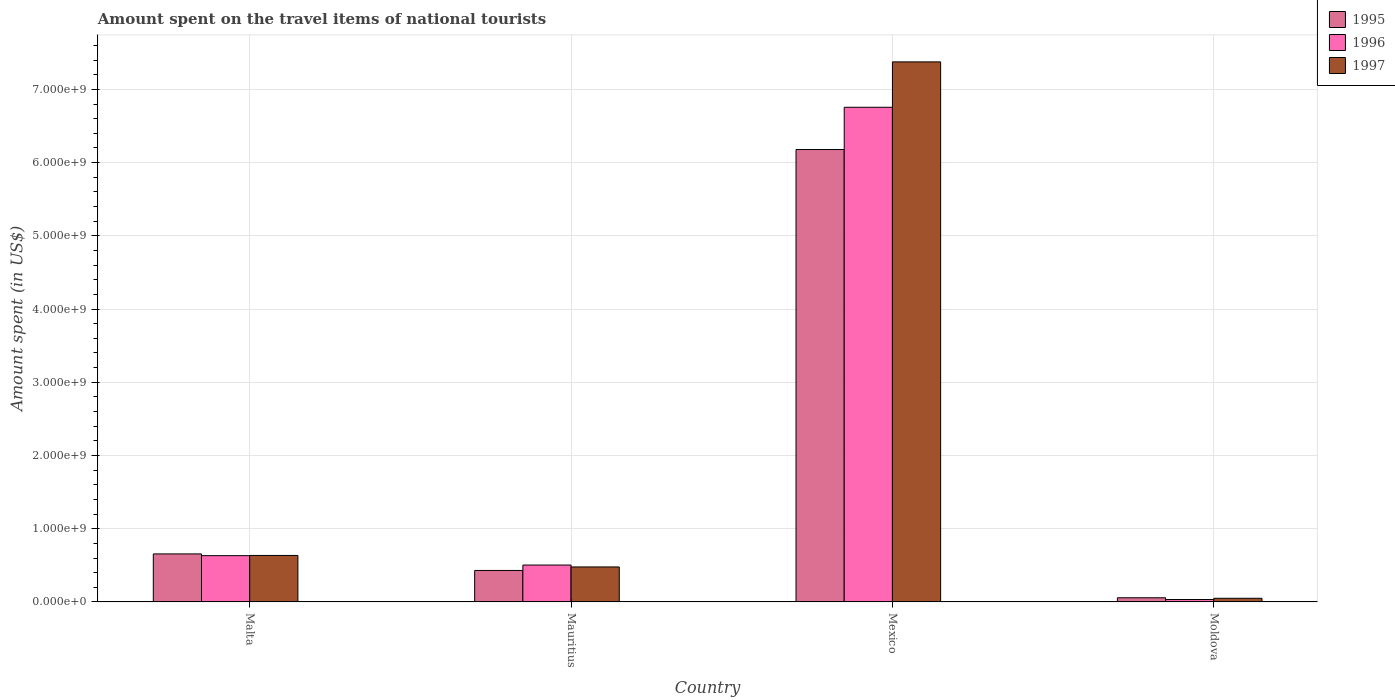How many bars are there on the 3rd tick from the right?
Keep it short and to the point. 3. What is the amount spent on the travel items of national tourists in 1996 in Mexico?
Provide a succinct answer. 6.76e+09. Across all countries, what is the maximum amount spent on the travel items of national tourists in 1996?
Keep it short and to the point. 6.76e+09. Across all countries, what is the minimum amount spent on the travel items of national tourists in 1995?
Provide a short and direct response. 5.70e+07. In which country was the amount spent on the travel items of national tourists in 1996 maximum?
Keep it short and to the point. Mexico. In which country was the amount spent on the travel items of national tourists in 1996 minimum?
Ensure brevity in your answer.  Moldova. What is the total amount spent on the travel items of national tourists in 1995 in the graph?
Offer a very short reply. 7.32e+09. What is the difference between the amount spent on the travel items of national tourists in 1996 in Mauritius and that in Moldova?
Provide a short and direct response. 4.71e+08. What is the difference between the amount spent on the travel items of national tourists in 1997 in Malta and the amount spent on the travel items of national tourists in 1996 in Moldova?
Offer a terse response. 6.02e+08. What is the average amount spent on the travel items of national tourists in 1995 per country?
Provide a succinct answer. 1.83e+09. What is the difference between the amount spent on the travel items of national tourists of/in 1995 and amount spent on the travel items of national tourists of/in 1996 in Malta?
Offer a very short reply. 2.40e+07. In how many countries, is the amount spent on the travel items of national tourists in 1995 greater than 5800000000 US$?
Make the answer very short. 1. What is the ratio of the amount spent on the travel items of national tourists in 1997 in Mauritius to that in Moldova?
Offer a very short reply. 9.56. Is the amount spent on the travel items of national tourists in 1995 in Malta less than that in Moldova?
Give a very brief answer. No. What is the difference between the highest and the second highest amount spent on the travel items of national tourists in 1997?
Keep it short and to the point. 6.90e+09. What is the difference between the highest and the lowest amount spent on the travel items of national tourists in 1997?
Provide a succinct answer. 7.33e+09. In how many countries, is the amount spent on the travel items of national tourists in 1995 greater than the average amount spent on the travel items of national tourists in 1995 taken over all countries?
Give a very brief answer. 1. Is the sum of the amount spent on the travel items of national tourists in 1995 in Mexico and Moldova greater than the maximum amount spent on the travel items of national tourists in 1997 across all countries?
Offer a terse response. No. What does the 3rd bar from the left in Moldova represents?
Offer a terse response. 1997. How many bars are there?
Make the answer very short. 12. Are all the bars in the graph horizontal?
Your response must be concise. No. How many countries are there in the graph?
Give a very brief answer. 4. Are the values on the major ticks of Y-axis written in scientific E-notation?
Provide a succinct answer. Yes. Does the graph contain grids?
Your response must be concise. Yes. Where does the legend appear in the graph?
Your response must be concise. Top right. How are the legend labels stacked?
Offer a terse response. Vertical. What is the title of the graph?
Provide a short and direct response. Amount spent on the travel items of national tourists. What is the label or title of the X-axis?
Your answer should be very brief. Country. What is the label or title of the Y-axis?
Make the answer very short. Amount spent (in US$). What is the Amount spent (in US$) in 1995 in Malta?
Your answer should be very brief. 6.56e+08. What is the Amount spent (in US$) of 1996 in Malta?
Make the answer very short. 6.32e+08. What is the Amount spent (in US$) in 1997 in Malta?
Keep it short and to the point. 6.35e+08. What is the Amount spent (in US$) of 1995 in Mauritius?
Keep it short and to the point. 4.30e+08. What is the Amount spent (in US$) in 1996 in Mauritius?
Make the answer very short. 5.04e+08. What is the Amount spent (in US$) in 1997 in Mauritius?
Make the answer very short. 4.78e+08. What is the Amount spent (in US$) of 1995 in Mexico?
Keep it short and to the point. 6.18e+09. What is the Amount spent (in US$) of 1996 in Mexico?
Offer a very short reply. 6.76e+09. What is the Amount spent (in US$) of 1997 in Mexico?
Your answer should be very brief. 7.38e+09. What is the Amount spent (in US$) of 1995 in Moldova?
Offer a terse response. 5.70e+07. What is the Amount spent (in US$) in 1996 in Moldova?
Your response must be concise. 3.30e+07. What is the Amount spent (in US$) of 1997 in Moldova?
Provide a succinct answer. 5.00e+07. Across all countries, what is the maximum Amount spent (in US$) in 1995?
Make the answer very short. 6.18e+09. Across all countries, what is the maximum Amount spent (in US$) in 1996?
Your response must be concise. 6.76e+09. Across all countries, what is the maximum Amount spent (in US$) of 1997?
Provide a succinct answer. 7.38e+09. Across all countries, what is the minimum Amount spent (in US$) of 1995?
Your response must be concise. 5.70e+07. Across all countries, what is the minimum Amount spent (in US$) in 1996?
Provide a succinct answer. 3.30e+07. What is the total Amount spent (in US$) in 1995 in the graph?
Keep it short and to the point. 7.32e+09. What is the total Amount spent (in US$) of 1996 in the graph?
Your answer should be very brief. 7.92e+09. What is the total Amount spent (in US$) in 1997 in the graph?
Keep it short and to the point. 8.54e+09. What is the difference between the Amount spent (in US$) in 1995 in Malta and that in Mauritius?
Offer a very short reply. 2.26e+08. What is the difference between the Amount spent (in US$) of 1996 in Malta and that in Mauritius?
Offer a terse response. 1.28e+08. What is the difference between the Amount spent (in US$) of 1997 in Malta and that in Mauritius?
Offer a very short reply. 1.57e+08. What is the difference between the Amount spent (in US$) in 1995 in Malta and that in Mexico?
Your answer should be compact. -5.52e+09. What is the difference between the Amount spent (in US$) of 1996 in Malta and that in Mexico?
Provide a succinct answer. -6.12e+09. What is the difference between the Amount spent (in US$) in 1997 in Malta and that in Mexico?
Provide a succinct answer. -6.74e+09. What is the difference between the Amount spent (in US$) in 1995 in Malta and that in Moldova?
Provide a short and direct response. 5.99e+08. What is the difference between the Amount spent (in US$) of 1996 in Malta and that in Moldova?
Provide a short and direct response. 5.99e+08. What is the difference between the Amount spent (in US$) in 1997 in Malta and that in Moldova?
Offer a very short reply. 5.85e+08. What is the difference between the Amount spent (in US$) of 1995 in Mauritius and that in Mexico?
Offer a terse response. -5.75e+09. What is the difference between the Amount spent (in US$) in 1996 in Mauritius and that in Mexico?
Ensure brevity in your answer.  -6.25e+09. What is the difference between the Amount spent (in US$) of 1997 in Mauritius and that in Mexico?
Give a very brief answer. -6.90e+09. What is the difference between the Amount spent (in US$) of 1995 in Mauritius and that in Moldova?
Ensure brevity in your answer.  3.73e+08. What is the difference between the Amount spent (in US$) in 1996 in Mauritius and that in Moldova?
Provide a short and direct response. 4.71e+08. What is the difference between the Amount spent (in US$) in 1997 in Mauritius and that in Moldova?
Your answer should be compact. 4.28e+08. What is the difference between the Amount spent (in US$) of 1995 in Mexico and that in Moldova?
Your answer should be very brief. 6.12e+09. What is the difference between the Amount spent (in US$) of 1996 in Mexico and that in Moldova?
Your answer should be compact. 6.72e+09. What is the difference between the Amount spent (in US$) of 1997 in Mexico and that in Moldova?
Provide a succinct answer. 7.33e+09. What is the difference between the Amount spent (in US$) of 1995 in Malta and the Amount spent (in US$) of 1996 in Mauritius?
Ensure brevity in your answer.  1.52e+08. What is the difference between the Amount spent (in US$) in 1995 in Malta and the Amount spent (in US$) in 1997 in Mauritius?
Your answer should be very brief. 1.78e+08. What is the difference between the Amount spent (in US$) in 1996 in Malta and the Amount spent (in US$) in 1997 in Mauritius?
Ensure brevity in your answer.  1.54e+08. What is the difference between the Amount spent (in US$) in 1995 in Malta and the Amount spent (in US$) in 1996 in Mexico?
Your response must be concise. -6.10e+09. What is the difference between the Amount spent (in US$) of 1995 in Malta and the Amount spent (in US$) of 1997 in Mexico?
Give a very brief answer. -6.72e+09. What is the difference between the Amount spent (in US$) of 1996 in Malta and the Amount spent (in US$) of 1997 in Mexico?
Offer a very short reply. -6.74e+09. What is the difference between the Amount spent (in US$) in 1995 in Malta and the Amount spent (in US$) in 1996 in Moldova?
Your response must be concise. 6.23e+08. What is the difference between the Amount spent (in US$) in 1995 in Malta and the Amount spent (in US$) in 1997 in Moldova?
Your answer should be very brief. 6.06e+08. What is the difference between the Amount spent (in US$) in 1996 in Malta and the Amount spent (in US$) in 1997 in Moldova?
Your answer should be compact. 5.82e+08. What is the difference between the Amount spent (in US$) of 1995 in Mauritius and the Amount spent (in US$) of 1996 in Mexico?
Provide a short and direct response. -6.33e+09. What is the difference between the Amount spent (in US$) of 1995 in Mauritius and the Amount spent (in US$) of 1997 in Mexico?
Make the answer very short. -6.95e+09. What is the difference between the Amount spent (in US$) of 1996 in Mauritius and the Amount spent (in US$) of 1997 in Mexico?
Offer a very short reply. -6.87e+09. What is the difference between the Amount spent (in US$) in 1995 in Mauritius and the Amount spent (in US$) in 1996 in Moldova?
Offer a very short reply. 3.97e+08. What is the difference between the Amount spent (in US$) of 1995 in Mauritius and the Amount spent (in US$) of 1997 in Moldova?
Offer a very short reply. 3.80e+08. What is the difference between the Amount spent (in US$) in 1996 in Mauritius and the Amount spent (in US$) in 1997 in Moldova?
Keep it short and to the point. 4.54e+08. What is the difference between the Amount spent (in US$) in 1995 in Mexico and the Amount spent (in US$) in 1996 in Moldova?
Your answer should be compact. 6.15e+09. What is the difference between the Amount spent (in US$) in 1995 in Mexico and the Amount spent (in US$) in 1997 in Moldova?
Give a very brief answer. 6.13e+09. What is the difference between the Amount spent (in US$) of 1996 in Mexico and the Amount spent (in US$) of 1997 in Moldova?
Provide a succinct answer. 6.71e+09. What is the average Amount spent (in US$) of 1995 per country?
Give a very brief answer. 1.83e+09. What is the average Amount spent (in US$) of 1996 per country?
Offer a very short reply. 1.98e+09. What is the average Amount spent (in US$) in 1997 per country?
Your answer should be very brief. 2.13e+09. What is the difference between the Amount spent (in US$) in 1995 and Amount spent (in US$) in 1996 in Malta?
Offer a very short reply. 2.40e+07. What is the difference between the Amount spent (in US$) of 1995 and Amount spent (in US$) of 1997 in Malta?
Your answer should be very brief. 2.10e+07. What is the difference between the Amount spent (in US$) of 1996 and Amount spent (in US$) of 1997 in Malta?
Keep it short and to the point. -3.00e+06. What is the difference between the Amount spent (in US$) of 1995 and Amount spent (in US$) of 1996 in Mauritius?
Your response must be concise. -7.40e+07. What is the difference between the Amount spent (in US$) in 1995 and Amount spent (in US$) in 1997 in Mauritius?
Ensure brevity in your answer.  -4.80e+07. What is the difference between the Amount spent (in US$) in 1996 and Amount spent (in US$) in 1997 in Mauritius?
Provide a succinct answer. 2.60e+07. What is the difference between the Amount spent (in US$) in 1995 and Amount spent (in US$) in 1996 in Mexico?
Provide a succinct answer. -5.77e+08. What is the difference between the Amount spent (in US$) in 1995 and Amount spent (in US$) in 1997 in Mexico?
Your answer should be compact. -1.20e+09. What is the difference between the Amount spent (in US$) of 1996 and Amount spent (in US$) of 1997 in Mexico?
Provide a succinct answer. -6.20e+08. What is the difference between the Amount spent (in US$) of 1995 and Amount spent (in US$) of 1996 in Moldova?
Keep it short and to the point. 2.40e+07. What is the difference between the Amount spent (in US$) in 1995 and Amount spent (in US$) in 1997 in Moldova?
Make the answer very short. 7.00e+06. What is the difference between the Amount spent (in US$) of 1996 and Amount spent (in US$) of 1997 in Moldova?
Offer a terse response. -1.70e+07. What is the ratio of the Amount spent (in US$) in 1995 in Malta to that in Mauritius?
Give a very brief answer. 1.53. What is the ratio of the Amount spent (in US$) in 1996 in Malta to that in Mauritius?
Offer a terse response. 1.25. What is the ratio of the Amount spent (in US$) in 1997 in Malta to that in Mauritius?
Your answer should be very brief. 1.33. What is the ratio of the Amount spent (in US$) of 1995 in Malta to that in Mexico?
Make the answer very short. 0.11. What is the ratio of the Amount spent (in US$) of 1996 in Malta to that in Mexico?
Ensure brevity in your answer.  0.09. What is the ratio of the Amount spent (in US$) in 1997 in Malta to that in Mexico?
Offer a very short reply. 0.09. What is the ratio of the Amount spent (in US$) in 1995 in Malta to that in Moldova?
Keep it short and to the point. 11.51. What is the ratio of the Amount spent (in US$) of 1996 in Malta to that in Moldova?
Ensure brevity in your answer.  19.15. What is the ratio of the Amount spent (in US$) of 1997 in Malta to that in Moldova?
Provide a succinct answer. 12.7. What is the ratio of the Amount spent (in US$) of 1995 in Mauritius to that in Mexico?
Offer a terse response. 0.07. What is the ratio of the Amount spent (in US$) of 1996 in Mauritius to that in Mexico?
Give a very brief answer. 0.07. What is the ratio of the Amount spent (in US$) of 1997 in Mauritius to that in Mexico?
Provide a short and direct response. 0.06. What is the ratio of the Amount spent (in US$) in 1995 in Mauritius to that in Moldova?
Provide a short and direct response. 7.54. What is the ratio of the Amount spent (in US$) in 1996 in Mauritius to that in Moldova?
Give a very brief answer. 15.27. What is the ratio of the Amount spent (in US$) in 1997 in Mauritius to that in Moldova?
Your answer should be very brief. 9.56. What is the ratio of the Amount spent (in US$) of 1995 in Mexico to that in Moldova?
Your response must be concise. 108.4. What is the ratio of the Amount spent (in US$) of 1996 in Mexico to that in Moldova?
Your answer should be very brief. 204.73. What is the ratio of the Amount spent (in US$) of 1997 in Mexico to that in Moldova?
Your answer should be compact. 147.52. What is the difference between the highest and the second highest Amount spent (in US$) of 1995?
Provide a succinct answer. 5.52e+09. What is the difference between the highest and the second highest Amount spent (in US$) in 1996?
Your response must be concise. 6.12e+09. What is the difference between the highest and the second highest Amount spent (in US$) of 1997?
Your answer should be compact. 6.74e+09. What is the difference between the highest and the lowest Amount spent (in US$) in 1995?
Your answer should be very brief. 6.12e+09. What is the difference between the highest and the lowest Amount spent (in US$) of 1996?
Give a very brief answer. 6.72e+09. What is the difference between the highest and the lowest Amount spent (in US$) of 1997?
Your answer should be compact. 7.33e+09. 